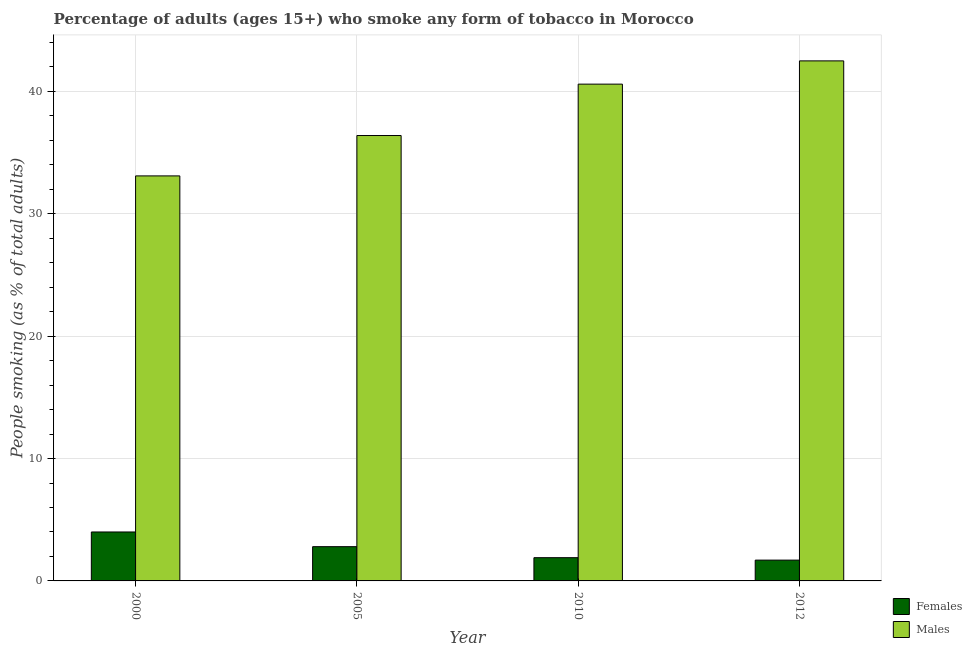How many different coloured bars are there?
Your answer should be compact. 2. How many groups of bars are there?
Give a very brief answer. 4. How many bars are there on the 1st tick from the left?
Your response must be concise. 2. What is the label of the 1st group of bars from the left?
Give a very brief answer. 2000. In how many cases, is the number of bars for a given year not equal to the number of legend labels?
Provide a succinct answer. 0. What is the percentage of females who smoke in 2012?
Your response must be concise. 1.7. Across all years, what is the minimum percentage of males who smoke?
Keep it short and to the point. 33.1. In which year was the percentage of males who smoke maximum?
Provide a short and direct response. 2012. In which year was the percentage of females who smoke minimum?
Offer a very short reply. 2012. What is the total percentage of males who smoke in the graph?
Provide a succinct answer. 152.6. What is the average percentage of females who smoke per year?
Offer a very short reply. 2.6. In how many years, is the percentage of males who smoke greater than 40 %?
Provide a succinct answer. 2. What is the ratio of the percentage of males who smoke in 2000 to that in 2005?
Provide a succinct answer. 0.91. What is the difference between the highest and the second highest percentage of females who smoke?
Offer a very short reply. 1.2. What is the difference between the highest and the lowest percentage of males who smoke?
Keep it short and to the point. 9.4. In how many years, is the percentage of males who smoke greater than the average percentage of males who smoke taken over all years?
Provide a short and direct response. 2. What does the 1st bar from the left in 2010 represents?
Keep it short and to the point. Females. What does the 2nd bar from the right in 2010 represents?
Provide a short and direct response. Females. How many bars are there?
Provide a short and direct response. 8. How many years are there in the graph?
Give a very brief answer. 4. What is the difference between two consecutive major ticks on the Y-axis?
Your answer should be very brief. 10. Are the values on the major ticks of Y-axis written in scientific E-notation?
Your answer should be very brief. No. Does the graph contain any zero values?
Provide a succinct answer. No. How are the legend labels stacked?
Provide a short and direct response. Vertical. What is the title of the graph?
Your answer should be compact. Percentage of adults (ages 15+) who smoke any form of tobacco in Morocco. Does "Highest 10% of population" appear as one of the legend labels in the graph?
Offer a terse response. No. What is the label or title of the Y-axis?
Your response must be concise. People smoking (as % of total adults). What is the People smoking (as % of total adults) in Females in 2000?
Keep it short and to the point. 4. What is the People smoking (as % of total adults) in Males in 2000?
Your answer should be compact. 33.1. What is the People smoking (as % of total adults) in Males in 2005?
Give a very brief answer. 36.4. What is the People smoking (as % of total adults) of Females in 2010?
Your answer should be very brief. 1.9. What is the People smoking (as % of total adults) of Males in 2010?
Provide a short and direct response. 40.6. What is the People smoking (as % of total adults) in Females in 2012?
Give a very brief answer. 1.7. What is the People smoking (as % of total adults) of Males in 2012?
Your response must be concise. 42.5. Across all years, what is the maximum People smoking (as % of total adults) of Males?
Your response must be concise. 42.5. Across all years, what is the minimum People smoking (as % of total adults) in Males?
Offer a very short reply. 33.1. What is the total People smoking (as % of total adults) in Females in the graph?
Ensure brevity in your answer.  10.4. What is the total People smoking (as % of total adults) of Males in the graph?
Keep it short and to the point. 152.6. What is the difference between the People smoking (as % of total adults) in Females in 2000 and that in 2005?
Your response must be concise. 1.2. What is the difference between the People smoking (as % of total adults) of Males in 2000 and that in 2005?
Provide a succinct answer. -3.3. What is the difference between the People smoking (as % of total adults) in Males in 2000 and that in 2010?
Make the answer very short. -7.5. What is the difference between the People smoking (as % of total adults) of Males in 2000 and that in 2012?
Give a very brief answer. -9.4. What is the difference between the People smoking (as % of total adults) of Females in 2005 and that in 2010?
Offer a very short reply. 0.9. What is the difference between the People smoking (as % of total adults) in Males in 2005 and that in 2010?
Give a very brief answer. -4.2. What is the difference between the People smoking (as % of total adults) of Males in 2005 and that in 2012?
Your answer should be compact. -6.1. What is the difference between the People smoking (as % of total adults) in Females in 2000 and the People smoking (as % of total adults) in Males in 2005?
Provide a short and direct response. -32.4. What is the difference between the People smoking (as % of total adults) of Females in 2000 and the People smoking (as % of total adults) of Males in 2010?
Offer a terse response. -36.6. What is the difference between the People smoking (as % of total adults) in Females in 2000 and the People smoking (as % of total adults) in Males in 2012?
Ensure brevity in your answer.  -38.5. What is the difference between the People smoking (as % of total adults) of Females in 2005 and the People smoking (as % of total adults) of Males in 2010?
Give a very brief answer. -37.8. What is the difference between the People smoking (as % of total adults) of Females in 2005 and the People smoking (as % of total adults) of Males in 2012?
Your answer should be very brief. -39.7. What is the difference between the People smoking (as % of total adults) in Females in 2010 and the People smoking (as % of total adults) in Males in 2012?
Provide a succinct answer. -40.6. What is the average People smoking (as % of total adults) in Females per year?
Your answer should be very brief. 2.6. What is the average People smoking (as % of total adults) of Males per year?
Ensure brevity in your answer.  38.15. In the year 2000, what is the difference between the People smoking (as % of total adults) in Females and People smoking (as % of total adults) in Males?
Offer a terse response. -29.1. In the year 2005, what is the difference between the People smoking (as % of total adults) in Females and People smoking (as % of total adults) in Males?
Make the answer very short. -33.6. In the year 2010, what is the difference between the People smoking (as % of total adults) of Females and People smoking (as % of total adults) of Males?
Offer a very short reply. -38.7. In the year 2012, what is the difference between the People smoking (as % of total adults) in Females and People smoking (as % of total adults) in Males?
Make the answer very short. -40.8. What is the ratio of the People smoking (as % of total adults) in Females in 2000 to that in 2005?
Ensure brevity in your answer.  1.43. What is the ratio of the People smoking (as % of total adults) of Males in 2000 to that in 2005?
Provide a short and direct response. 0.91. What is the ratio of the People smoking (as % of total adults) in Females in 2000 to that in 2010?
Ensure brevity in your answer.  2.11. What is the ratio of the People smoking (as % of total adults) of Males in 2000 to that in 2010?
Provide a succinct answer. 0.82. What is the ratio of the People smoking (as % of total adults) of Females in 2000 to that in 2012?
Offer a terse response. 2.35. What is the ratio of the People smoking (as % of total adults) in Males in 2000 to that in 2012?
Offer a very short reply. 0.78. What is the ratio of the People smoking (as % of total adults) of Females in 2005 to that in 2010?
Offer a terse response. 1.47. What is the ratio of the People smoking (as % of total adults) of Males in 2005 to that in 2010?
Offer a very short reply. 0.9. What is the ratio of the People smoking (as % of total adults) of Females in 2005 to that in 2012?
Keep it short and to the point. 1.65. What is the ratio of the People smoking (as % of total adults) of Males in 2005 to that in 2012?
Provide a short and direct response. 0.86. What is the ratio of the People smoking (as % of total adults) of Females in 2010 to that in 2012?
Offer a very short reply. 1.12. What is the ratio of the People smoking (as % of total adults) of Males in 2010 to that in 2012?
Your answer should be compact. 0.96. What is the difference between the highest and the second highest People smoking (as % of total adults) in Females?
Offer a terse response. 1.2. What is the difference between the highest and the lowest People smoking (as % of total adults) in Males?
Offer a terse response. 9.4. 